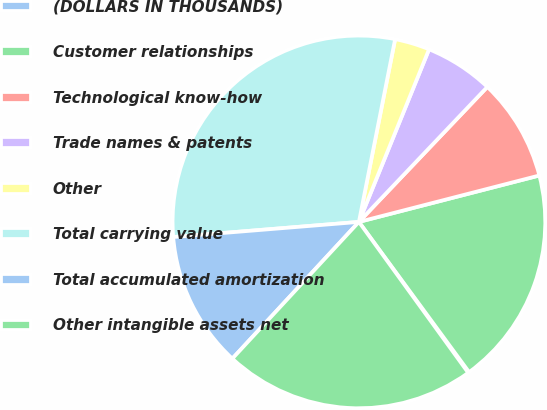Convert chart to OTSL. <chart><loc_0><loc_0><loc_500><loc_500><pie_chart><fcel>(DOLLARS IN THOUSANDS)<fcel>Customer relationships<fcel>Technological know-how<fcel>Trade names & patents<fcel>Other<fcel>Total carrying value<fcel>Total accumulated amortization<fcel>Other intangible assets net<nl><fcel>0.09%<fcel>18.94%<fcel>8.89%<fcel>5.96%<fcel>3.03%<fcel>29.41%<fcel>11.82%<fcel>21.87%<nl></chart> 